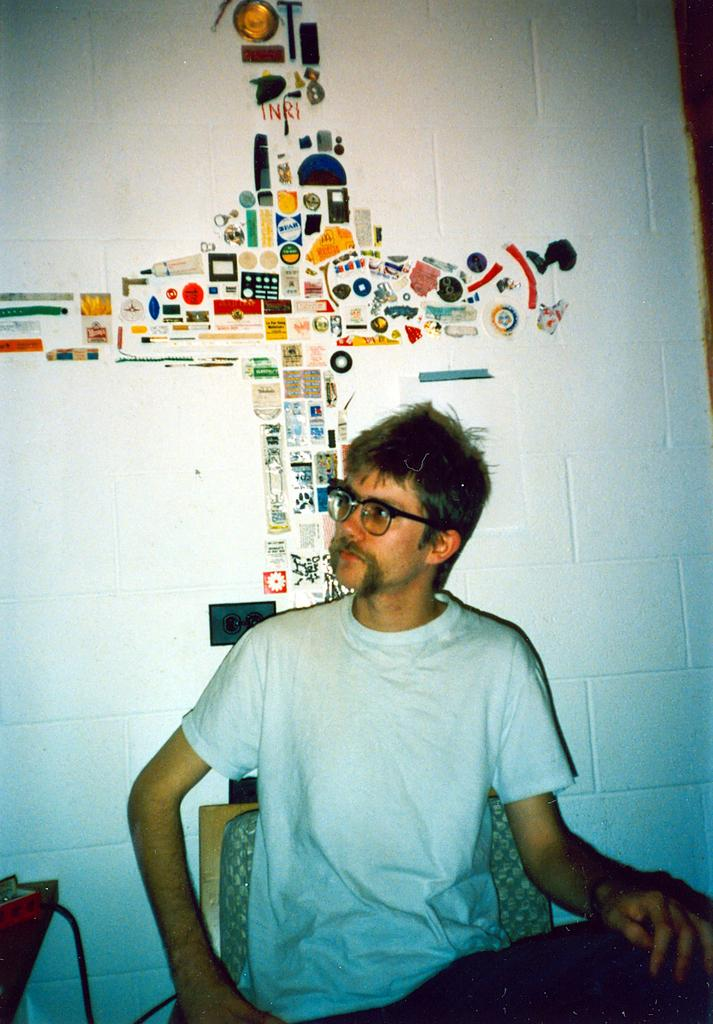What is the man in the image doing? The man is sitting on a chair in the image. Can you describe the man's appearance? The man is wearing spectacles in the image. What can be seen on the wall behind the man? There is a painting on the wall behind the man. What else is visible in the image? There is a cable and an object beside the man. What type of test is the man conducting in the image? There is no test being conducted in the image; the man is simply sitting on a chair. 